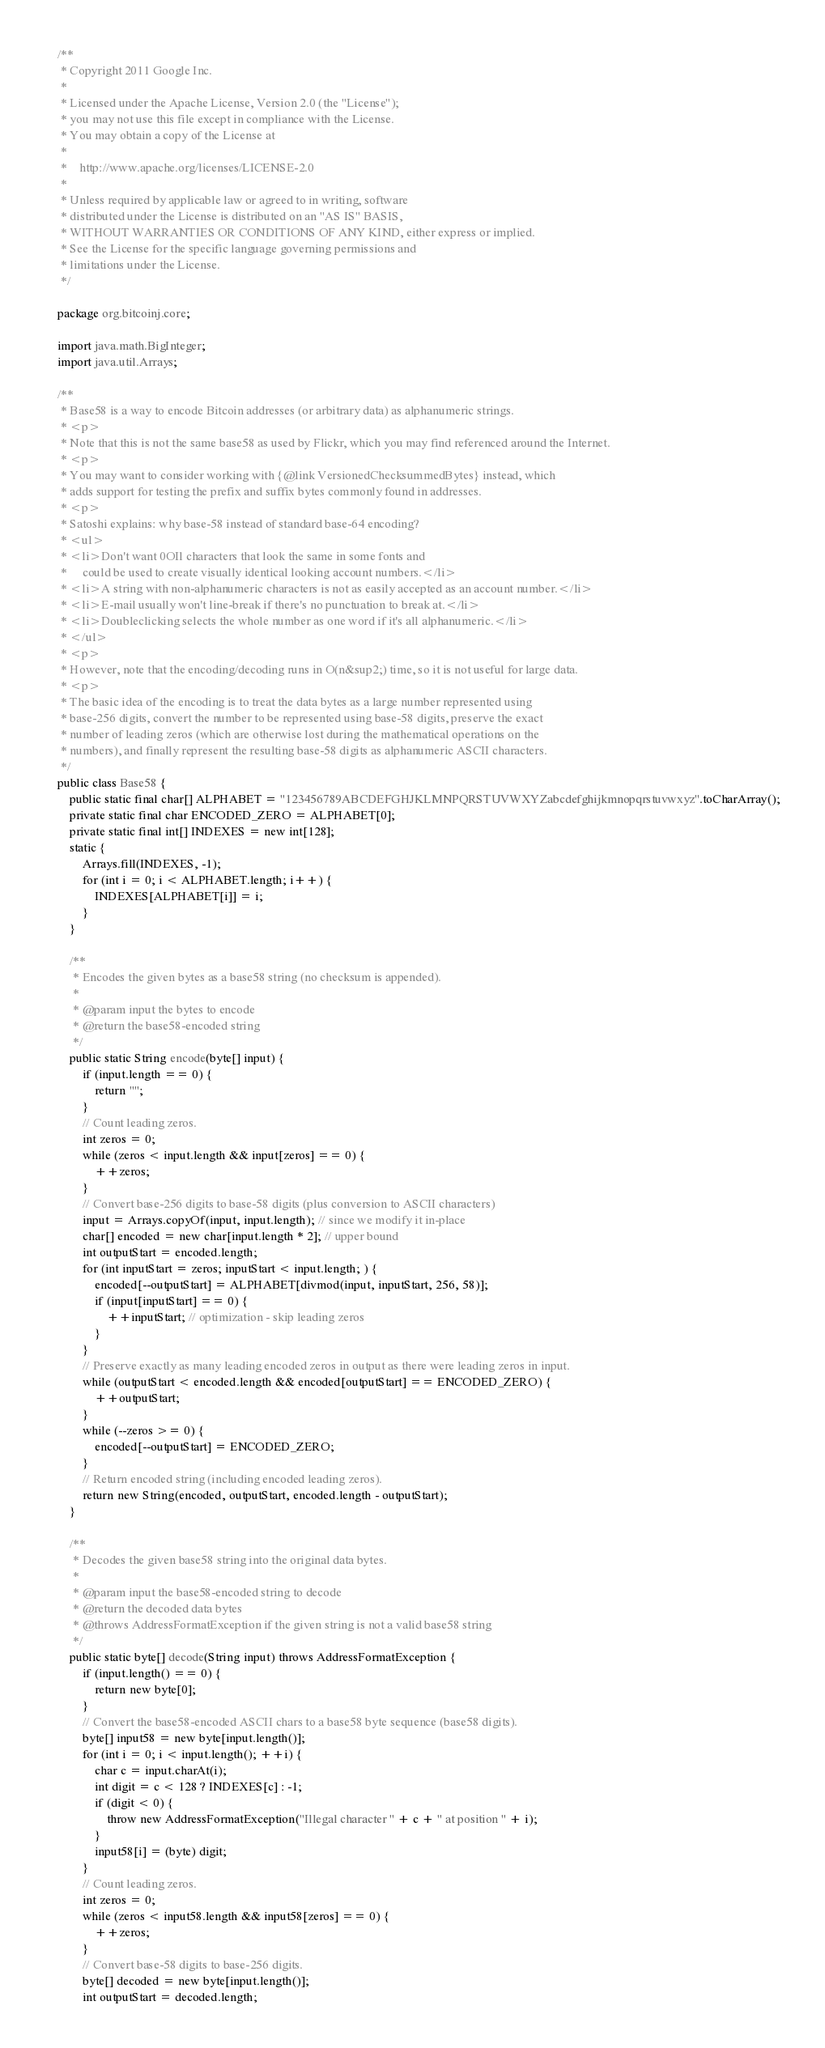Convert code to text. <code><loc_0><loc_0><loc_500><loc_500><_Java_>/**
 * Copyright 2011 Google Inc.
 *
 * Licensed under the Apache License, Version 2.0 (the "License");
 * you may not use this file except in compliance with the License.
 * You may obtain a copy of the License at
 *
 *    http://www.apache.org/licenses/LICENSE-2.0
 *
 * Unless required by applicable law or agreed to in writing, software
 * distributed under the License is distributed on an "AS IS" BASIS,
 * WITHOUT WARRANTIES OR CONDITIONS OF ANY KIND, either express or implied.
 * See the License for the specific language governing permissions and
 * limitations under the License.
 */

package org.bitcoinj.core;

import java.math.BigInteger;
import java.util.Arrays;

/**
 * Base58 is a way to encode Bitcoin addresses (or arbitrary data) as alphanumeric strings.
 * <p>
 * Note that this is not the same base58 as used by Flickr, which you may find referenced around the Internet.
 * <p>
 * You may want to consider working with {@link VersionedChecksummedBytes} instead, which
 * adds support for testing the prefix and suffix bytes commonly found in addresses.
 * <p>
 * Satoshi explains: why base-58 instead of standard base-64 encoding?
 * <ul>
 * <li>Don't want 0OIl characters that look the same in some fonts and
 *     could be used to create visually identical looking account numbers.</li>
 * <li>A string with non-alphanumeric characters is not as easily accepted as an account number.</li>
 * <li>E-mail usually won't line-break if there's no punctuation to break at.</li>
 * <li>Doubleclicking selects the whole number as one word if it's all alphanumeric.</li>
 * </ul>
 * <p>
 * However, note that the encoding/decoding runs in O(n&sup2;) time, so it is not useful for large data.
 * <p>
 * The basic idea of the encoding is to treat the data bytes as a large number represented using
 * base-256 digits, convert the number to be represented using base-58 digits, preserve the exact
 * number of leading zeros (which are otherwise lost during the mathematical operations on the
 * numbers), and finally represent the resulting base-58 digits as alphanumeric ASCII characters.
 */
public class Base58 {
    public static final char[] ALPHABET = "123456789ABCDEFGHJKLMNPQRSTUVWXYZabcdefghijkmnopqrstuvwxyz".toCharArray();
    private static final char ENCODED_ZERO = ALPHABET[0];
    private static final int[] INDEXES = new int[128];
    static {
        Arrays.fill(INDEXES, -1);
        for (int i = 0; i < ALPHABET.length; i++) {
            INDEXES[ALPHABET[i]] = i;
        }
    }

    /**
     * Encodes the given bytes as a base58 string (no checksum is appended).
     *
     * @param input the bytes to encode
     * @return the base58-encoded string
     */
    public static String encode(byte[] input) {
        if (input.length == 0) {
            return "";
        }       
        // Count leading zeros.
        int zeros = 0;
        while (zeros < input.length && input[zeros] == 0) {
            ++zeros;
        }
        // Convert base-256 digits to base-58 digits (plus conversion to ASCII characters)
        input = Arrays.copyOf(input, input.length); // since we modify it in-place
        char[] encoded = new char[input.length * 2]; // upper bound
        int outputStart = encoded.length;
        for (int inputStart = zeros; inputStart < input.length; ) {
            encoded[--outputStart] = ALPHABET[divmod(input, inputStart, 256, 58)];
            if (input[inputStart] == 0) {
                ++inputStart; // optimization - skip leading zeros
            }
        }
        // Preserve exactly as many leading encoded zeros in output as there were leading zeros in input.
        while (outputStart < encoded.length && encoded[outputStart] == ENCODED_ZERO) {
            ++outputStart;
        }
        while (--zeros >= 0) {
            encoded[--outputStart] = ENCODED_ZERO;
        }
        // Return encoded string (including encoded leading zeros).
        return new String(encoded, outputStart, encoded.length - outputStart);
    }

    /**
     * Decodes the given base58 string into the original data bytes.
     *
     * @param input the base58-encoded string to decode
     * @return the decoded data bytes
     * @throws AddressFormatException if the given string is not a valid base58 string
     */
    public static byte[] decode(String input) throws AddressFormatException {
        if (input.length() == 0) {
            return new byte[0];
        }
        // Convert the base58-encoded ASCII chars to a base58 byte sequence (base58 digits).
        byte[] input58 = new byte[input.length()];
        for (int i = 0; i < input.length(); ++i) {
            char c = input.charAt(i);
            int digit = c < 128 ? INDEXES[c] : -1;
            if (digit < 0) {
                throw new AddressFormatException("Illegal character " + c + " at position " + i);
            }
            input58[i] = (byte) digit;
        }
        // Count leading zeros.
        int zeros = 0;
        while (zeros < input58.length && input58[zeros] == 0) {
            ++zeros;
        }
        // Convert base-58 digits to base-256 digits.
        byte[] decoded = new byte[input.length()];
        int outputStart = decoded.length;</code> 